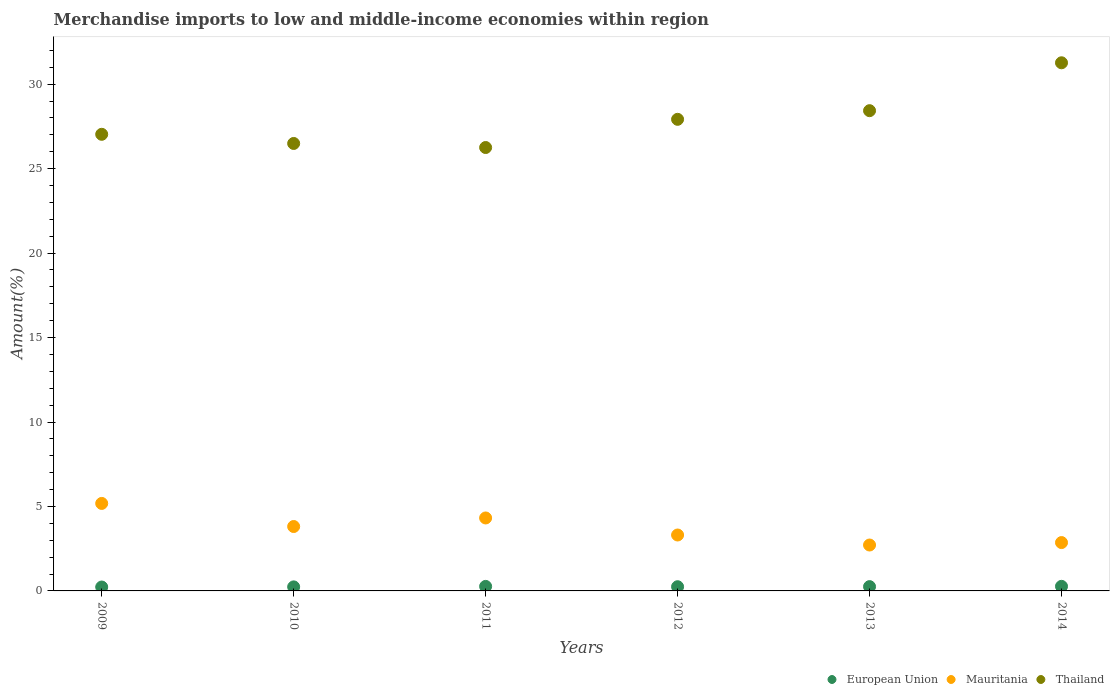Is the number of dotlines equal to the number of legend labels?
Provide a succinct answer. Yes. What is the percentage of amount earned from merchandise imports in Thailand in 2014?
Ensure brevity in your answer.  31.27. Across all years, what is the maximum percentage of amount earned from merchandise imports in European Union?
Your answer should be very brief. 0.27. Across all years, what is the minimum percentage of amount earned from merchandise imports in European Union?
Keep it short and to the point. 0.23. In which year was the percentage of amount earned from merchandise imports in Mauritania maximum?
Make the answer very short. 2009. What is the total percentage of amount earned from merchandise imports in Thailand in the graph?
Give a very brief answer. 167.39. What is the difference between the percentage of amount earned from merchandise imports in Mauritania in 2011 and that in 2014?
Your answer should be very brief. 1.46. What is the difference between the percentage of amount earned from merchandise imports in Mauritania in 2012 and the percentage of amount earned from merchandise imports in European Union in 2009?
Keep it short and to the point. 3.08. What is the average percentage of amount earned from merchandise imports in Thailand per year?
Your answer should be compact. 27.9. In the year 2011, what is the difference between the percentage of amount earned from merchandise imports in Mauritania and percentage of amount earned from merchandise imports in Thailand?
Offer a very short reply. -21.93. What is the ratio of the percentage of amount earned from merchandise imports in Mauritania in 2012 to that in 2014?
Make the answer very short. 1.16. Is the percentage of amount earned from merchandise imports in European Union in 2010 less than that in 2012?
Make the answer very short. Yes. What is the difference between the highest and the second highest percentage of amount earned from merchandise imports in Thailand?
Provide a short and direct response. 2.84. What is the difference between the highest and the lowest percentage of amount earned from merchandise imports in Mauritania?
Your response must be concise. 2.46. Is it the case that in every year, the sum of the percentage of amount earned from merchandise imports in European Union and percentage of amount earned from merchandise imports in Mauritania  is greater than the percentage of amount earned from merchandise imports in Thailand?
Your response must be concise. No. Is the percentage of amount earned from merchandise imports in Mauritania strictly greater than the percentage of amount earned from merchandise imports in European Union over the years?
Ensure brevity in your answer.  Yes. Is the percentage of amount earned from merchandise imports in European Union strictly less than the percentage of amount earned from merchandise imports in Thailand over the years?
Offer a terse response. Yes. How many dotlines are there?
Your answer should be compact. 3. How many years are there in the graph?
Provide a short and direct response. 6. Are the values on the major ticks of Y-axis written in scientific E-notation?
Your answer should be very brief. No. How many legend labels are there?
Offer a very short reply. 3. What is the title of the graph?
Provide a short and direct response. Merchandise imports to low and middle-income economies within region. What is the label or title of the Y-axis?
Provide a short and direct response. Amount(%). What is the Amount(%) of European Union in 2009?
Your answer should be compact. 0.23. What is the Amount(%) of Mauritania in 2009?
Your answer should be very brief. 5.18. What is the Amount(%) in Thailand in 2009?
Keep it short and to the point. 27.03. What is the Amount(%) in European Union in 2010?
Offer a very short reply. 0.24. What is the Amount(%) in Mauritania in 2010?
Your response must be concise. 3.81. What is the Amount(%) of Thailand in 2010?
Keep it short and to the point. 26.49. What is the Amount(%) in European Union in 2011?
Keep it short and to the point. 0.27. What is the Amount(%) of Mauritania in 2011?
Make the answer very short. 4.32. What is the Amount(%) in Thailand in 2011?
Ensure brevity in your answer.  26.25. What is the Amount(%) in European Union in 2012?
Your answer should be compact. 0.25. What is the Amount(%) of Mauritania in 2012?
Give a very brief answer. 3.31. What is the Amount(%) of Thailand in 2012?
Your answer should be very brief. 27.92. What is the Amount(%) of European Union in 2013?
Provide a succinct answer. 0.25. What is the Amount(%) of Mauritania in 2013?
Your answer should be compact. 2.72. What is the Amount(%) of Thailand in 2013?
Provide a succinct answer. 28.43. What is the Amount(%) of European Union in 2014?
Offer a very short reply. 0.27. What is the Amount(%) of Mauritania in 2014?
Ensure brevity in your answer.  2.86. What is the Amount(%) in Thailand in 2014?
Your answer should be very brief. 31.27. Across all years, what is the maximum Amount(%) in European Union?
Ensure brevity in your answer.  0.27. Across all years, what is the maximum Amount(%) of Mauritania?
Your response must be concise. 5.18. Across all years, what is the maximum Amount(%) in Thailand?
Offer a very short reply. 31.27. Across all years, what is the minimum Amount(%) in European Union?
Ensure brevity in your answer.  0.23. Across all years, what is the minimum Amount(%) of Mauritania?
Offer a very short reply. 2.72. Across all years, what is the minimum Amount(%) in Thailand?
Your answer should be compact. 26.25. What is the total Amount(%) of European Union in the graph?
Your answer should be compact. 1.51. What is the total Amount(%) in Mauritania in the graph?
Offer a very short reply. 22.2. What is the total Amount(%) in Thailand in the graph?
Offer a very short reply. 167.39. What is the difference between the Amount(%) in European Union in 2009 and that in 2010?
Keep it short and to the point. -0.01. What is the difference between the Amount(%) of Mauritania in 2009 and that in 2010?
Offer a very short reply. 1.37. What is the difference between the Amount(%) of Thailand in 2009 and that in 2010?
Keep it short and to the point. 0.54. What is the difference between the Amount(%) in European Union in 2009 and that in 2011?
Your answer should be very brief. -0.04. What is the difference between the Amount(%) in Mauritania in 2009 and that in 2011?
Keep it short and to the point. 0.86. What is the difference between the Amount(%) in Thailand in 2009 and that in 2011?
Your response must be concise. 0.78. What is the difference between the Amount(%) of European Union in 2009 and that in 2012?
Make the answer very short. -0.02. What is the difference between the Amount(%) of Mauritania in 2009 and that in 2012?
Provide a succinct answer. 1.87. What is the difference between the Amount(%) of Thailand in 2009 and that in 2012?
Give a very brief answer. -0.89. What is the difference between the Amount(%) in European Union in 2009 and that in 2013?
Give a very brief answer. -0.02. What is the difference between the Amount(%) in Mauritania in 2009 and that in 2013?
Provide a succinct answer. 2.46. What is the difference between the Amount(%) of Thailand in 2009 and that in 2013?
Make the answer very short. -1.4. What is the difference between the Amount(%) in European Union in 2009 and that in 2014?
Make the answer very short. -0.04. What is the difference between the Amount(%) in Mauritania in 2009 and that in 2014?
Your answer should be compact. 2.32. What is the difference between the Amount(%) in Thailand in 2009 and that in 2014?
Ensure brevity in your answer.  -4.23. What is the difference between the Amount(%) of European Union in 2010 and that in 2011?
Make the answer very short. -0.03. What is the difference between the Amount(%) in Mauritania in 2010 and that in 2011?
Offer a very short reply. -0.51. What is the difference between the Amount(%) of Thailand in 2010 and that in 2011?
Offer a very short reply. 0.24. What is the difference between the Amount(%) in European Union in 2010 and that in 2012?
Give a very brief answer. -0.01. What is the difference between the Amount(%) of Mauritania in 2010 and that in 2012?
Offer a terse response. 0.5. What is the difference between the Amount(%) in Thailand in 2010 and that in 2012?
Offer a terse response. -1.43. What is the difference between the Amount(%) in European Union in 2010 and that in 2013?
Your response must be concise. -0.02. What is the difference between the Amount(%) in Mauritania in 2010 and that in 2013?
Offer a very short reply. 1.1. What is the difference between the Amount(%) in Thailand in 2010 and that in 2013?
Offer a very short reply. -1.94. What is the difference between the Amount(%) in European Union in 2010 and that in 2014?
Offer a terse response. -0.03. What is the difference between the Amount(%) of Mauritania in 2010 and that in 2014?
Offer a terse response. 0.95. What is the difference between the Amount(%) of Thailand in 2010 and that in 2014?
Provide a succinct answer. -4.78. What is the difference between the Amount(%) in European Union in 2011 and that in 2012?
Provide a succinct answer. 0.02. What is the difference between the Amount(%) in Mauritania in 2011 and that in 2012?
Provide a short and direct response. 1.01. What is the difference between the Amount(%) of Thailand in 2011 and that in 2012?
Your response must be concise. -1.67. What is the difference between the Amount(%) of European Union in 2011 and that in 2013?
Offer a terse response. 0.01. What is the difference between the Amount(%) of Mauritania in 2011 and that in 2013?
Keep it short and to the point. 1.6. What is the difference between the Amount(%) in Thailand in 2011 and that in 2013?
Offer a very short reply. -2.18. What is the difference between the Amount(%) in European Union in 2011 and that in 2014?
Ensure brevity in your answer.  -0. What is the difference between the Amount(%) of Mauritania in 2011 and that in 2014?
Your answer should be very brief. 1.46. What is the difference between the Amount(%) of Thailand in 2011 and that in 2014?
Offer a terse response. -5.02. What is the difference between the Amount(%) of European Union in 2012 and that in 2013?
Your answer should be compact. -0.01. What is the difference between the Amount(%) in Mauritania in 2012 and that in 2013?
Ensure brevity in your answer.  0.59. What is the difference between the Amount(%) of Thailand in 2012 and that in 2013?
Ensure brevity in your answer.  -0.51. What is the difference between the Amount(%) in European Union in 2012 and that in 2014?
Make the answer very short. -0.02. What is the difference between the Amount(%) in Mauritania in 2012 and that in 2014?
Offer a very short reply. 0.45. What is the difference between the Amount(%) of Thailand in 2012 and that in 2014?
Ensure brevity in your answer.  -3.35. What is the difference between the Amount(%) in European Union in 2013 and that in 2014?
Your response must be concise. -0.02. What is the difference between the Amount(%) in Mauritania in 2013 and that in 2014?
Keep it short and to the point. -0.14. What is the difference between the Amount(%) of Thailand in 2013 and that in 2014?
Offer a very short reply. -2.84. What is the difference between the Amount(%) in European Union in 2009 and the Amount(%) in Mauritania in 2010?
Provide a short and direct response. -3.58. What is the difference between the Amount(%) of European Union in 2009 and the Amount(%) of Thailand in 2010?
Offer a very short reply. -26.26. What is the difference between the Amount(%) of Mauritania in 2009 and the Amount(%) of Thailand in 2010?
Ensure brevity in your answer.  -21.31. What is the difference between the Amount(%) in European Union in 2009 and the Amount(%) in Mauritania in 2011?
Make the answer very short. -4.09. What is the difference between the Amount(%) of European Union in 2009 and the Amount(%) of Thailand in 2011?
Provide a short and direct response. -26.02. What is the difference between the Amount(%) in Mauritania in 2009 and the Amount(%) in Thailand in 2011?
Offer a very short reply. -21.07. What is the difference between the Amount(%) in European Union in 2009 and the Amount(%) in Mauritania in 2012?
Your answer should be compact. -3.08. What is the difference between the Amount(%) of European Union in 2009 and the Amount(%) of Thailand in 2012?
Provide a succinct answer. -27.69. What is the difference between the Amount(%) of Mauritania in 2009 and the Amount(%) of Thailand in 2012?
Your response must be concise. -22.74. What is the difference between the Amount(%) of European Union in 2009 and the Amount(%) of Mauritania in 2013?
Provide a short and direct response. -2.49. What is the difference between the Amount(%) in European Union in 2009 and the Amount(%) in Thailand in 2013?
Provide a succinct answer. -28.2. What is the difference between the Amount(%) in Mauritania in 2009 and the Amount(%) in Thailand in 2013?
Provide a succinct answer. -23.25. What is the difference between the Amount(%) of European Union in 2009 and the Amount(%) of Mauritania in 2014?
Give a very brief answer. -2.63. What is the difference between the Amount(%) in European Union in 2009 and the Amount(%) in Thailand in 2014?
Keep it short and to the point. -31.04. What is the difference between the Amount(%) of Mauritania in 2009 and the Amount(%) of Thailand in 2014?
Your response must be concise. -26.09. What is the difference between the Amount(%) of European Union in 2010 and the Amount(%) of Mauritania in 2011?
Provide a succinct answer. -4.08. What is the difference between the Amount(%) of European Union in 2010 and the Amount(%) of Thailand in 2011?
Give a very brief answer. -26.01. What is the difference between the Amount(%) in Mauritania in 2010 and the Amount(%) in Thailand in 2011?
Keep it short and to the point. -22.44. What is the difference between the Amount(%) of European Union in 2010 and the Amount(%) of Mauritania in 2012?
Your response must be concise. -3.07. What is the difference between the Amount(%) of European Union in 2010 and the Amount(%) of Thailand in 2012?
Keep it short and to the point. -27.68. What is the difference between the Amount(%) of Mauritania in 2010 and the Amount(%) of Thailand in 2012?
Provide a short and direct response. -24.11. What is the difference between the Amount(%) in European Union in 2010 and the Amount(%) in Mauritania in 2013?
Keep it short and to the point. -2.48. What is the difference between the Amount(%) in European Union in 2010 and the Amount(%) in Thailand in 2013?
Your response must be concise. -28.19. What is the difference between the Amount(%) in Mauritania in 2010 and the Amount(%) in Thailand in 2013?
Keep it short and to the point. -24.62. What is the difference between the Amount(%) in European Union in 2010 and the Amount(%) in Mauritania in 2014?
Your response must be concise. -2.62. What is the difference between the Amount(%) of European Union in 2010 and the Amount(%) of Thailand in 2014?
Ensure brevity in your answer.  -31.03. What is the difference between the Amount(%) of Mauritania in 2010 and the Amount(%) of Thailand in 2014?
Offer a very short reply. -27.45. What is the difference between the Amount(%) of European Union in 2011 and the Amount(%) of Mauritania in 2012?
Provide a short and direct response. -3.04. What is the difference between the Amount(%) in European Union in 2011 and the Amount(%) in Thailand in 2012?
Your answer should be compact. -27.65. What is the difference between the Amount(%) in Mauritania in 2011 and the Amount(%) in Thailand in 2012?
Make the answer very short. -23.6. What is the difference between the Amount(%) in European Union in 2011 and the Amount(%) in Mauritania in 2013?
Offer a terse response. -2.45. What is the difference between the Amount(%) of European Union in 2011 and the Amount(%) of Thailand in 2013?
Provide a succinct answer. -28.16. What is the difference between the Amount(%) of Mauritania in 2011 and the Amount(%) of Thailand in 2013?
Make the answer very short. -24.11. What is the difference between the Amount(%) in European Union in 2011 and the Amount(%) in Mauritania in 2014?
Your answer should be very brief. -2.59. What is the difference between the Amount(%) in European Union in 2011 and the Amount(%) in Thailand in 2014?
Offer a terse response. -31. What is the difference between the Amount(%) in Mauritania in 2011 and the Amount(%) in Thailand in 2014?
Give a very brief answer. -26.95. What is the difference between the Amount(%) in European Union in 2012 and the Amount(%) in Mauritania in 2013?
Offer a very short reply. -2.47. What is the difference between the Amount(%) in European Union in 2012 and the Amount(%) in Thailand in 2013?
Ensure brevity in your answer.  -28.18. What is the difference between the Amount(%) in Mauritania in 2012 and the Amount(%) in Thailand in 2013?
Your answer should be very brief. -25.12. What is the difference between the Amount(%) of European Union in 2012 and the Amount(%) of Mauritania in 2014?
Offer a very short reply. -2.61. What is the difference between the Amount(%) in European Union in 2012 and the Amount(%) in Thailand in 2014?
Offer a very short reply. -31.02. What is the difference between the Amount(%) in Mauritania in 2012 and the Amount(%) in Thailand in 2014?
Keep it short and to the point. -27.96. What is the difference between the Amount(%) of European Union in 2013 and the Amount(%) of Mauritania in 2014?
Your answer should be compact. -2.61. What is the difference between the Amount(%) in European Union in 2013 and the Amount(%) in Thailand in 2014?
Offer a terse response. -31.01. What is the difference between the Amount(%) in Mauritania in 2013 and the Amount(%) in Thailand in 2014?
Offer a terse response. -28.55. What is the average Amount(%) in European Union per year?
Offer a very short reply. 0.25. What is the average Amount(%) of Mauritania per year?
Offer a terse response. 3.7. What is the average Amount(%) of Thailand per year?
Provide a succinct answer. 27.9. In the year 2009, what is the difference between the Amount(%) of European Union and Amount(%) of Mauritania?
Give a very brief answer. -4.95. In the year 2009, what is the difference between the Amount(%) in European Union and Amount(%) in Thailand?
Provide a short and direct response. -26.8. In the year 2009, what is the difference between the Amount(%) in Mauritania and Amount(%) in Thailand?
Give a very brief answer. -21.85. In the year 2010, what is the difference between the Amount(%) in European Union and Amount(%) in Mauritania?
Ensure brevity in your answer.  -3.57. In the year 2010, what is the difference between the Amount(%) of European Union and Amount(%) of Thailand?
Provide a succinct answer. -26.25. In the year 2010, what is the difference between the Amount(%) in Mauritania and Amount(%) in Thailand?
Keep it short and to the point. -22.68. In the year 2011, what is the difference between the Amount(%) of European Union and Amount(%) of Mauritania?
Offer a very short reply. -4.05. In the year 2011, what is the difference between the Amount(%) in European Union and Amount(%) in Thailand?
Your answer should be compact. -25.98. In the year 2011, what is the difference between the Amount(%) in Mauritania and Amount(%) in Thailand?
Your answer should be very brief. -21.93. In the year 2012, what is the difference between the Amount(%) of European Union and Amount(%) of Mauritania?
Keep it short and to the point. -3.06. In the year 2012, what is the difference between the Amount(%) in European Union and Amount(%) in Thailand?
Offer a very short reply. -27.67. In the year 2012, what is the difference between the Amount(%) of Mauritania and Amount(%) of Thailand?
Offer a very short reply. -24.61. In the year 2013, what is the difference between the Amount(%) in European Union and Amount(%) in Mauritania?
Your answer should be compact. -2.46. In the year 2013, what is the difference between the Amount(%) of European Union and Amount(%) of Thailand?
Ensure brevity in your answer.  -28.18. In the year 2013, what is the difference between the Amount(%) of Mauritania and Amount(%) of Thailand?
Ensure brevity in your answer.  -25.71. In the year 2014, what is the difference between the Amount(%) of European Union and Amount(%) of Mauritania?
Provide a succinct answer. -2.59. In the year 2014, what is the difference between the Amount(%) of European Union and Amount(%) of Thailand?
Offer a terse response. -31. In the year 2014, what is the difference between the Amount(%) in Mauritania and Amount(%) in Thailand?
Offer a terse response. -28.4. What is the ratio of the Amount(%) of European Union in 2009 to that in 2010?
Give a very brief answer. 0.96. What is the ratio of the Amount(%) in Mauritania in 2009 to that in 2010?
Your answer should be very brief. 1.36. What is the ratio of the Amount(%) in Thailand in 2009 to that in 2010?
Offer a very short reply. 1.02. What is the ratio of the Amount(%) of European Union in 2009 to that in 2011?
Offer a terse response. 0.86. What is the ratio of the Amount(%) in Mauritania in 2009 to that in 2011?
Ensure brevity in your answer.  1.2. What is the ratio of the Amount(%) in Thailand in 2009 to that in 2011?
Your response must be concise. 1.03. What is the ratio of the Amount(%) in European Union in 2009 to that in 2012?
Offer a very short reply. 0.93. What is the ratio of the Amount(%) in Mauritania in 2009 to that in 2012?
Offer a very short reply. 1.56. What is the ratio of the Amount(%) of Thailand in 2009 to that in 2012?
Keep it short and to the point. 0.97. What is the ratio of the Amount(%) of European Union in 2009 to that in 2013?
Ensure brevity in your answer.  0.91. What is the ratio of the Amount(%) of Mauritania in 2009 to that in 2013?
Your response must be concise. 1.91. What is the ratio of the Amount(%) in Thailand in 2009 to that in 2013?
Offer a very short reply. 0.95. What is the ratio of the Amount(%) in European Union in 2009 to that in 2014?
Offer a very short reply. 0.85. What is the ratio of the Amount(%) in Mauritania in 2009 to that in 2014?
Offer a very short reply. 1.81. What is the ratio of the Amount(%) of Thailand in 2009 to that in 2014?
Your answer should be compact. 0.86. What is the ratio of the Amount(%) of European Union in 2010 to that in 2011?
Provide a short and direct response. 0.89. What is the ratio of the Amount(%) in Mauritania in 2010 to that in 2011?
Ensure brevity in your answer.  0.88. What is the ratio of the Amount(%) in Thailand in 2010 to that in 2011?
Your answer should be very brief. 1.01. What is the ratio of the Amount(%) of European Union in 2010 to that in 2012?
Your response must be concise. 0.96. What is the ratio of the Amount(%) in Mauritania in 2010 to that in 2012?
Your response must be concise. 1.15. What is the ratio of the Amount(%) in Thailand in 2010 to that in 2012?
Your answer should be compact. 0.95. What is the ratio of the Amount(%) of European Union in 2010 to that in 2013?
Your answer should be compact. 0.94. What is the ratio of the Amount(%) of Mauritania in 2010 to that in 2013?
Your response must be concise. 1.4. What is the ratio of the Amount(%) in Thailand in 2010 to that in 2013?
Your answer should be very brief. 0.93. What is the ratio of the Amount(%) in European Union in 2010 to that in 2014?
Ensure brevity in your answer.  0.88. What is the ratio of the Amount(%) in Mauritania in 2010 to that in 2014?
Provide a short and direct response. 1.33. What is the ratio of the Amount(%) in Thailand in 2010 to that in 2014?
Provide a short and direct response. 0.85. What is the ratio of the Amount(%) in European Union in 2011 to that in 2012?
Keep it short and to the point. 1.08. What is the ratio of the Amount(%) of Mauritania in 2011 to that in 2012?
Provide a succinct answer. 1.3. What is the ratio of the Amount(%) in Thailand in 2011 to that in 2012?
Your response must be concise. 0.94. What is the ratio of the Amount(%) in European Union in 2011 to that in 2013?
Offer a very short reply. 1.05. What is the ratio of the Amount(%) of Mauritania in 2011 to that in 2013?
Your answer should be very brief. 1.59. What is the ratio of the Amount(%) in Thailand in 2011 to that in 2013?
Keep it short and to the point. 0.92. What is the ratio of the Amount(%) in European Union in 2011 to that in 2014?
Make the answer very short. 0.99. What is the ratio of the Amount(%) in Mauritania in 2011 to that in 2014?
Your answer should be very brief. 1.51. What is the ratio of the Amount(%) of Thailand in 2011 to that in 2014?
Offer a very short reply. 0.84. What is the ratio of the Amount(%) of European Union in 2012 to that in 2013?
Make the answer very short. 0.98. What is the ratio of the Amount(%) of Mauritania in 2012 to that in 2013?
Your answer should be compact. 1.22. What is the ratio of the Amount(%) in Thailand in 2012 to that in 2013?
Ensure brevity in your answer.  0.98. What is the ratio of the Amount(%) in European Union in 2012 to that in 2014?
Keep it short and to the point. 0.92. What is the ratio of the Amount(%) in Mauritania in 2012 to that in 2014?
Make the answer very short. 1.16. What is the ratio of the Amount(%) in Thailand in 2012 to that in 2014?
Make the answer very short. 0.89. What is the ratio of the Amount(%) in European Union in 2013 to that in 2014?
Offer a terse response. 0.94. What is the ratio of the Amount(%) in Mauritania in 2013 to that in 2014?
Your answer should be very brief. 0.95. What is the ratio of the Amount(%) of Thailand in 2013 to that in 2014?
Give a very brief answer. 0.91. What is the difference between the highest and the second highest Amount(%) in European Union?
Ensure brevity in your answer.  0. What is the difference between the highest and the second highest Amount(%) of Mauritania?
Provide a short and direct response. 0.86. What is the difference between the highest and the second highest Amount(%) of Thailand?
Provide a succinct answer. 2.84. What is the difference between the highest and the lowest Amount(%) in European Union?
Offer a terse response. 0.04. What is the difference between the highest and the lowest Amount(%) of Mauritania?
Offer a very short reply. 2.46. What is the difference between the highest and the lowest Amount(%) of Thailand?
Give a very brief answer. 5.02. 